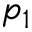Convert formula to latex. <formula><loc_0><loc_0><loc_500><loc_500>p _ { 1 }</formula> 